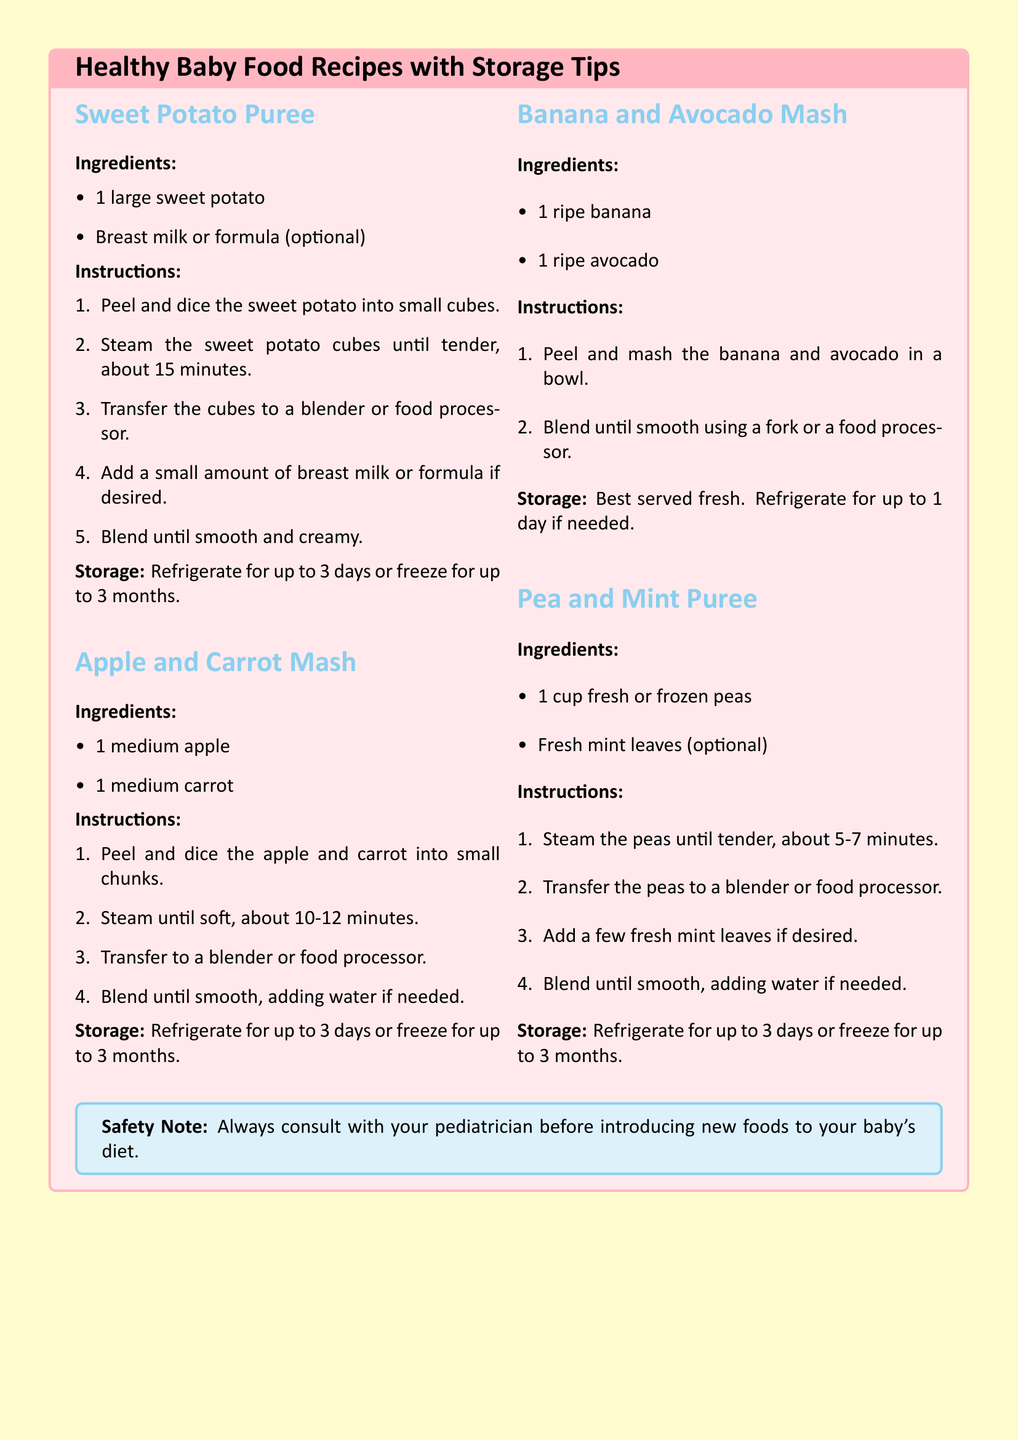What is the first recipe listed? The first recipe mentioned in the document is Sweet Potato Puree.
Answer: Sweet Potato Puree How many ingredients are in the Apple and Carrot Mash recipe? The ingredients listed for Apple and Carrot Mash include 2 items: 1 medium apple and 1 medium carrot.
Answer: 2 What is the recommended storage time for the Pea and Mint Puree? The storage time for Pea and Mint Puree is mentioned as refrigerate for up to 3 days or freeze for up to 3 months.
Answer: 3 days or 3 months Which recipe suggests adding breast milk or formula? The Sweet Potato Puree recipe suggests the option of adding breast milk or formula.
Answer: Sweet Potato Puree What is the color of the background in this recipe card? The document specifies the background color as soft yellow.
Answer: Soft yellow 